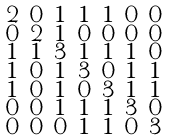Convert formula to latex. <formula><loc_0><loc_0><loc_500><loc_500>\begin{smallmatrix} 2 & 0 & 1 & 1 & 1 & 0 & 0 \\ 0 & 2 & 1 & 0 & 0 & 0 & 0 \\ 1 & 1 & 3 & 1 & 1 & 1 & 0 \\ 1 & 0 & 1 & 3 & 0 & 1 & 1 \\ 1 & 0 & 1 & 0 & 3 & 1 & 1 \\ 0 & 0 & 1 & 1 & 1 & 3 & 0 \\ 0 & 0 & 0 & 1 & 1 & 0 & 3 \end{smallmatrix}</formula> 